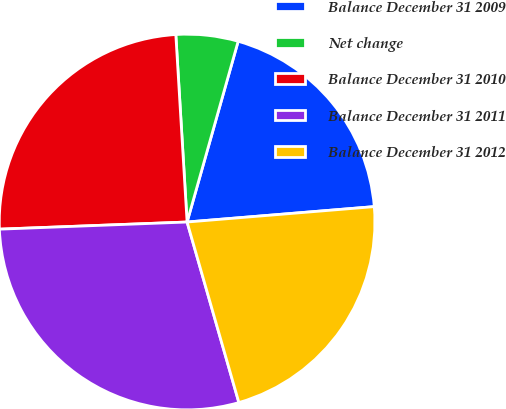<chart> <loc_0><loc_0><loc_500><loc_500><pie_chart><fcel>Balance December 31 2009<fcel>Net change<fcel>Balance December 31 2010<fcel>Balance December 31 2011<fcel>Balance December 31 2012<nl><fcel>19.31%<fcel>5.34%<fcel>24.65%<fcel>28.84%<fcel>21.86%<nl></chart> 